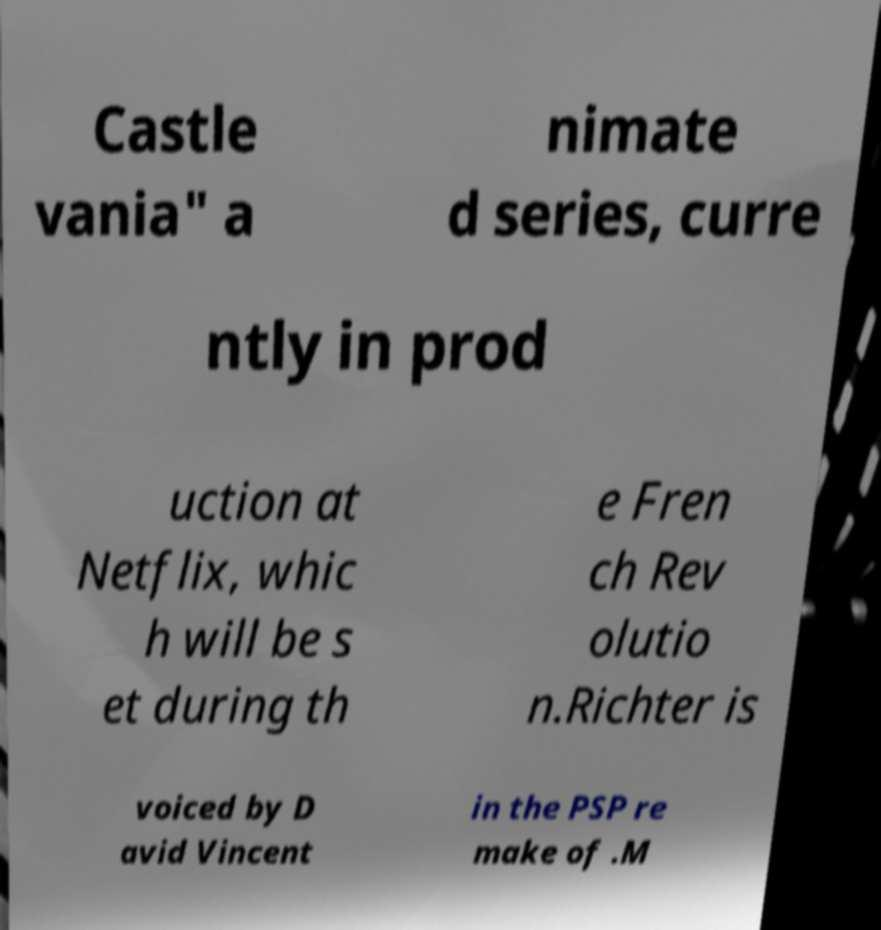I need the written content from this picture converted into text. Can you do that? Castle vania" a nimate d series, curre ntly in prod uction at Netflix, whic h will be s et during th e Fren ch Rev olutio n.Richter is voiced by D avid Vincent in the PSP re make of .M 